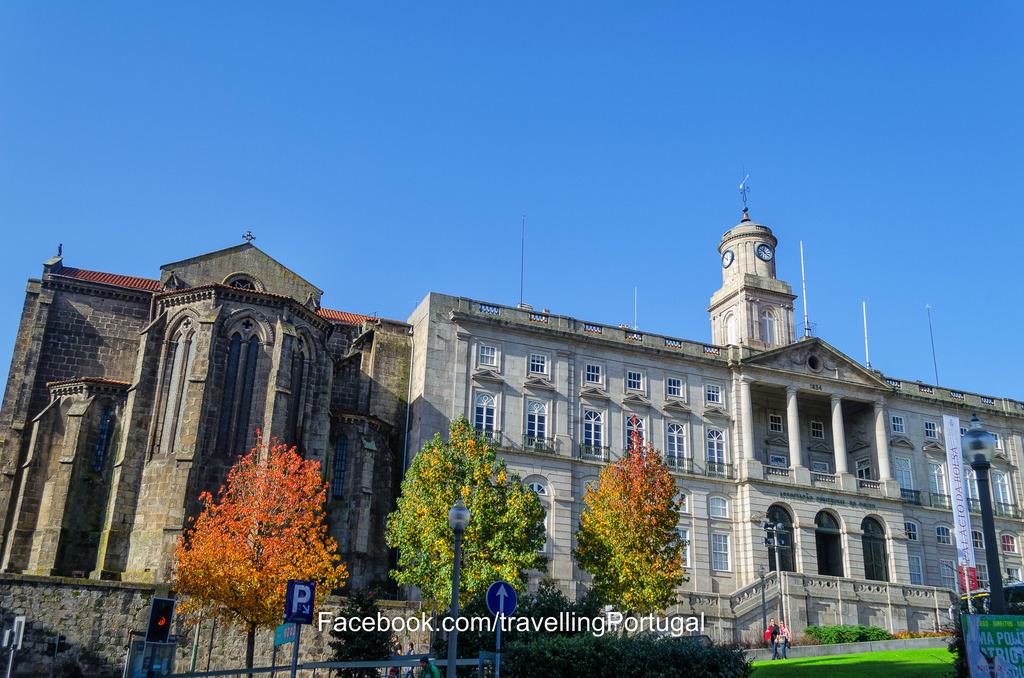What letter is shown on the sign in front of the tree?
Provide a succinct answer. P. 